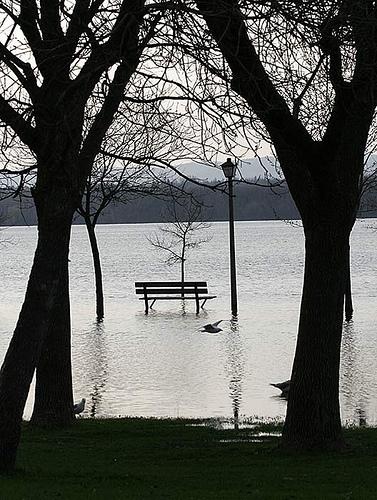What is this body of water called?
Concise answer only. Lake. Is the bench supposed to be in the water?
Give a very brief answer. No. Are there leaves on the trees?
Quick response, please. No. 